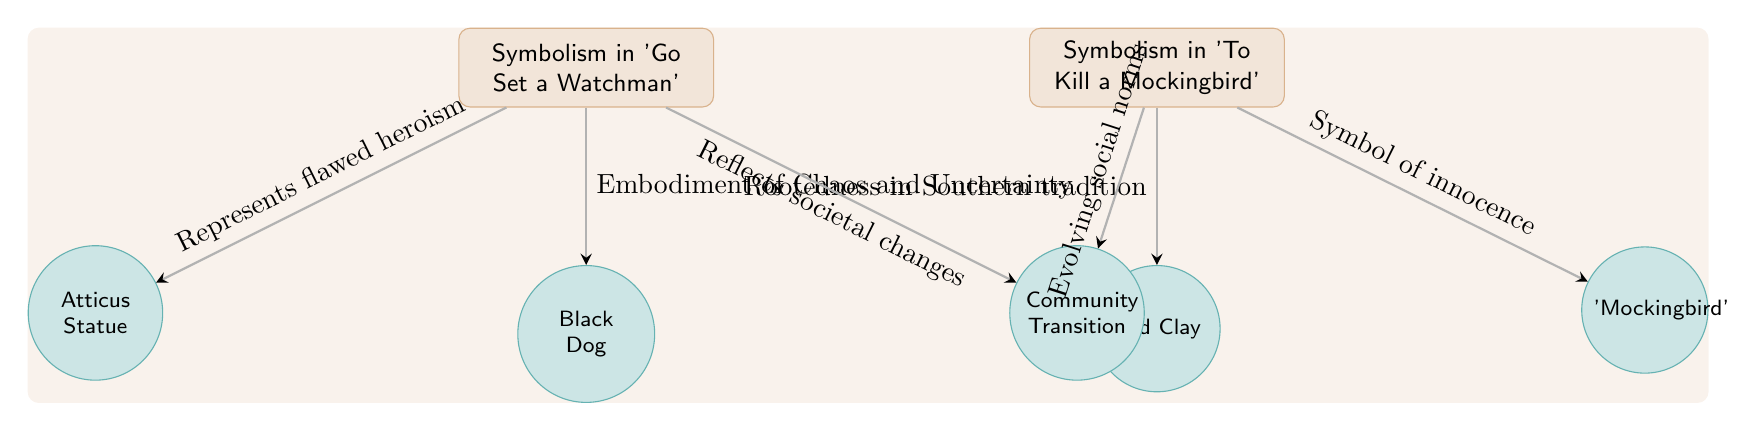What symbolizes flawed heroism in 'Go Set a Watchman'? The diagram indicates that the "Atticus Statue" represents flawed heroism in "Go Set a Watchman," showing a direct connection to the theme of the flawed hero in that context.
Answer: Atticus Statue Which symbol is linked to innocence in 'To Kill a Mockingbird'? According to the diagram, the "Mockingbird" is identified as the symbol of innocence in "To Kill a Mockingbird," illustrating the core theme of innocence in that narrative.
Answer: Mockingbird What motif is associated with chaos and uncertainty in 'Go Set a Watchman'? The diagram shows that the "Black Dog" symbolizes chaos and uncertainty in "Go Set a Watchman," reflecting themes of disorder and unpredictability within the story.
Answer: Black Dog What is the relationship between 'Go Set a Watchman' and community transition? The diagram depicts a direct relationship where "Go Set a Watchman" reflects societal changes through the motif of "Community Transition," showing an evolution in community dynamics.
Answer: Reflects societal changes How many symbols are connected to 'To Kill a Mockingbird'? The diagram reveals there are 2 symbols connected to "To Kill a Mockingbird," namely the "Mockingbird" and "Red Clay," each representing different thematic elements.
Answer: 2 What does the 'Red Clay' symbolize in the context of 'To Kill a Mockingbird'? In the diagram, "Red Clay" is connected to the narrative of "To Kill a Mockingbird" with the description "Rootedness in Southern tradition," indicating a link to the regional culture and heritage.
Answer: Rootedness in Southern tradition How does 'Go Set a Watchman' depict community transition? The diagram indicates that "Go Set a Watchman" relates to community transition through a connection labeled "Reflects societal changes," illustrating how the story portrays the shifts in community dynamics.
Answer: Reflects societal changes What concept is depicted between 'To Kill a Mockingbird' and evolving social norms? The diagram illustrates that "To Kill a Mockingbird" is linked to "Evolving social norms" through the community motif, emphasizing the changing moral landscapes within the novel.
Answer: Evolving social norms 